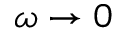Convert formula to latex. <formula><loc_0><loc_0><loc_500><loc_500>\omega \rightarrow 0</formula> 